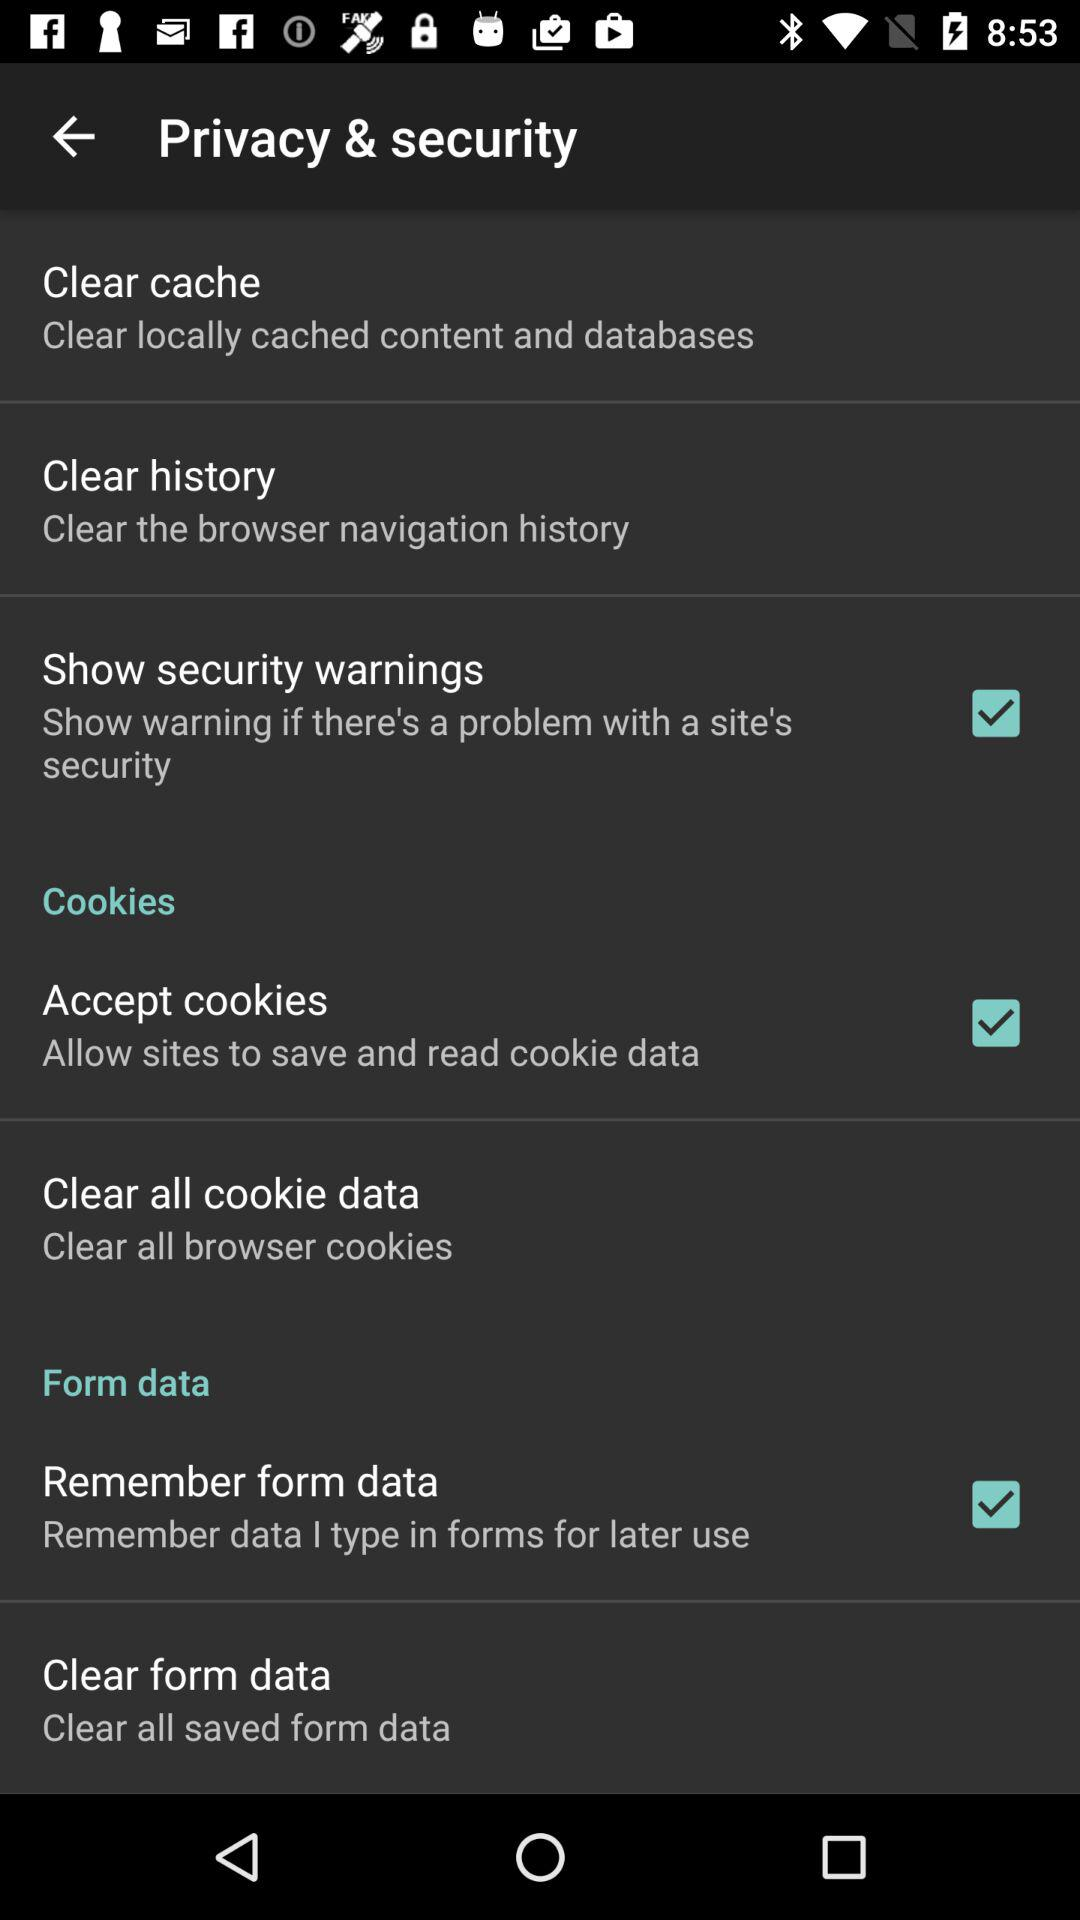What is the status of "Accept cookies"? The status is "on". 